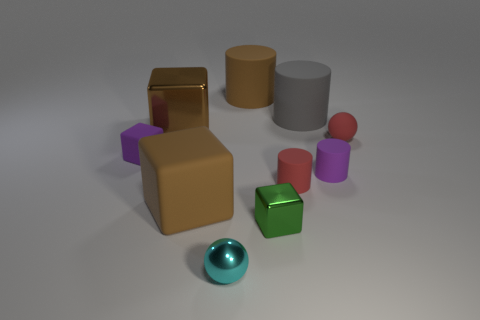Does the brown matte cylinder have the same size as the brown metallic cube?
Offer a terse response. Yes. What number of other objects are the same shape as the tiny cyan object?
Provide a short and direct response. 1. What is the shape of the purple matte thing that is on the right side of the green thing?
Offer a terse response. Cylinder. Is the shape of the large rubber thing in front of the tiny red matte cylinder the same as the purple rubber thing to the right of the big brown rubber cylinder?
Keep it short and to the point. No. Are there the same number of large shiny blocks to the right of the purple block and tiny red rubber spheres?
Your answer should be compact. Yes. Is there any other thing that has the same size as the cyan shiny sphere?
Keep it short and to the point. Yes. What material is the other large object that is the same shape as the big gray matte thing?
Offer a terse response. Rubber. The tiny red object behind the purple object that is on the left side of the purple matte cylinder is what shape?
Make the answer very short. Sphere. Does the ball to the right of the small cyan metal sphere have the same material as the cyan ball?
Give a very brief answer. No. Is the number of small green metallic cubes that are behind the big brown matte cube the same as the number of tiny cyan spheres that are right of the red rubber ball?
Keep it short and to the point. Yes. 